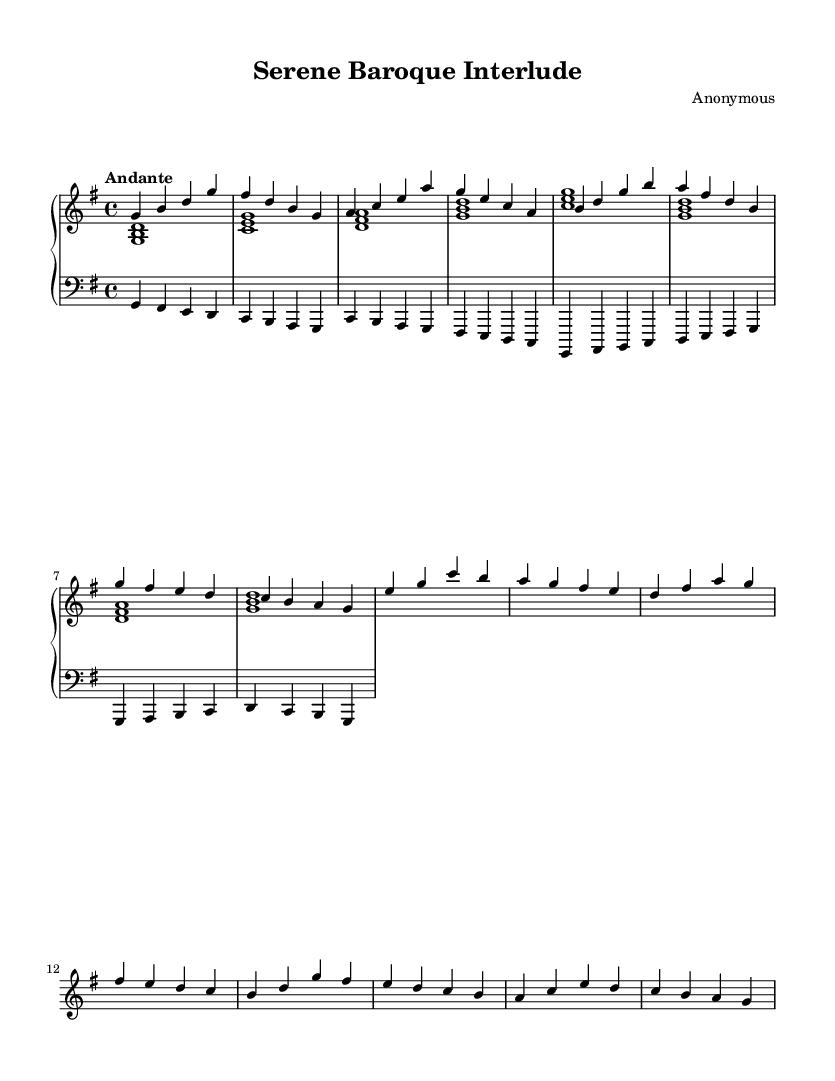What is the key signature of this music? The key signature is G major, which contains one sharp (F#) and is indicated at the beginning of the staff.
Answer: G major What is the time signature of this piece? The time signature shown at the beginning is 4/4, indicating that there are four beats per measure and the quarter note gets one beat.
Answer: 4/4 What is the tempo marking for this piece? The tempo marking is "Andante", which indicates a moderate pace that is generally considered to be walking speed.
Answer: Andante How many measures are in the melody section? By counting the measures of the melody section, there are a total of eight measures present in the A and B sections combined.
Answer: 8 What is the primary mood conveyed by this composition? Given the melodic line and harmonies, the primary mood is serene, characterized by smooth, flowing lines and gentle harmonic progressions.
Answer: Serene What is the instrument specified in the score for the right hand? The score has specified the instrument for the right hand as "harpsichord," which is typical for Baroque keyboard compositions.
Answer: Harpsichord Identify the type of musical form used in this piece. The composition employs a binary form, consisting of two contrasting sections (A and B), which is common in Baroque music.
Answer: Binary form 